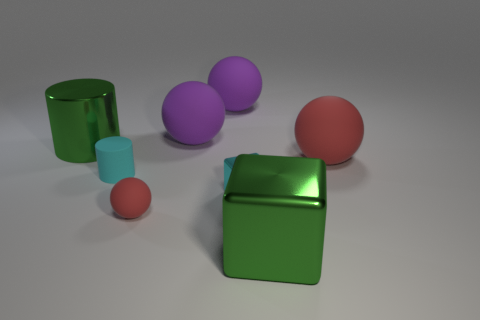Are there fewer big green cylinders than tiny green spheres? There are an equal number of big green cylinders and tiny green spheres in the image. Both the cylinders and the spheres appear as two distinct objects each, making the count even between the two described shapes and colors. 